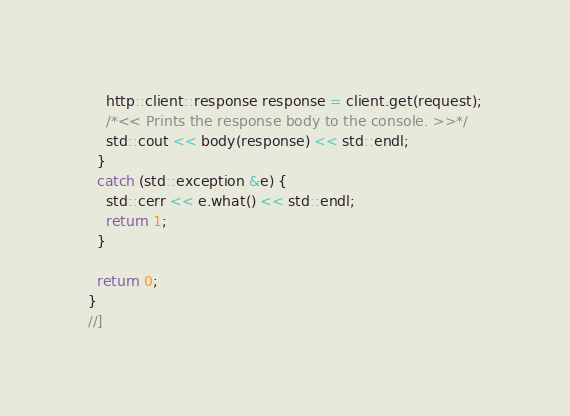Convert code to text. <code><loc_0><loc_0><loc_500><loc_500><_C++_>    http::client::response response = client.get(request);
    /*<< Prints the response body to the console. >>*/
    std::cout << body(response) << std::endl;
  }
  catch (std::exception &e) {
    std::cerr << e.what() << std::endl;
    return 1;
  }

  return 0;
}
//]
</code> 